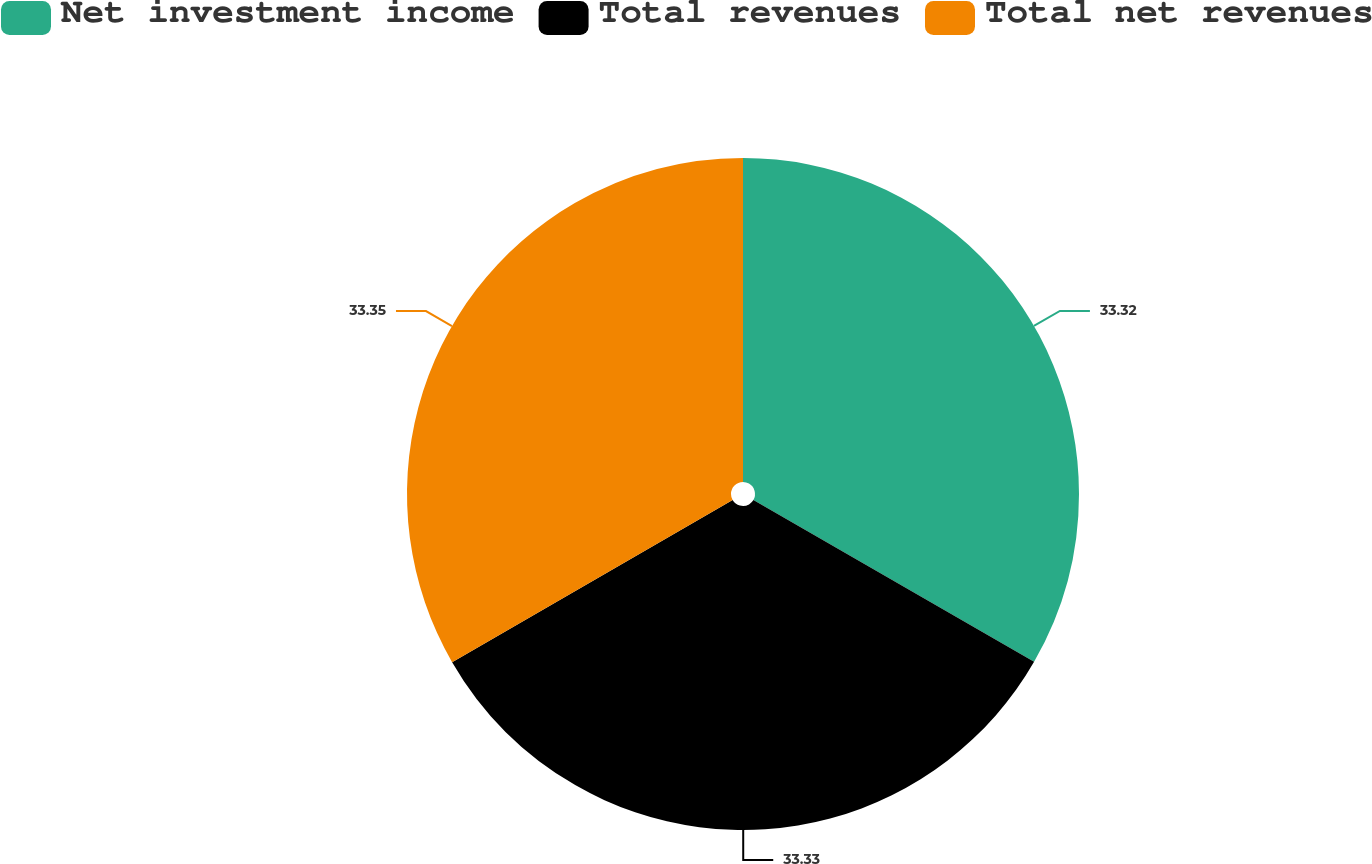Convert chart. <chart><loc_0><loc_0><loc_500><loc_500><pie_chart><fcel>Net investment income<fcel>Total revenues<fcel>Total net revenues<nl><fcel>33.32%<fcel>33.33%<fcel>33.34%<nl></chart> 